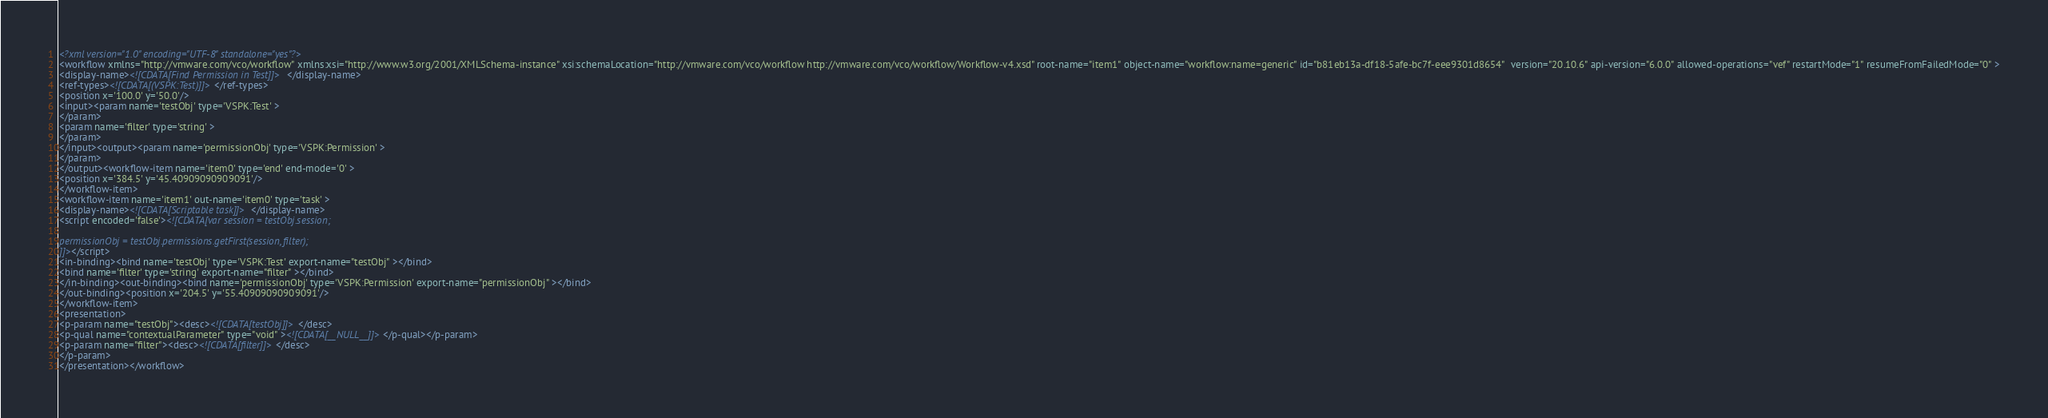Convert code to text. <code><loc_0><loc_0><loc_500><loc_500><_XML_><?xml version="1.0" encoding="UTF-8" standalone="yes"?>
<workflow xmlns="http://vmware.com/vco/workflow" xmlns:xsi="http://www.w3.org/2001/XMLSchema-instance" xsi:schemaLocation="http://vmware.com/vco/workflow http://vmware.com/vco/workflow/Workflow-v4.xsd" root-name="item1" object-name="workflow:name=generic" id="b81eb13a-df18-5afe-bc7f-eee9301d8654"  version="20.10.6" api-version="6.0.0" allowed-operations="vef" restartMode="1" resumeFromFailedMode="0" >
<display-name><![CDATA[Find Permission in Test]]></display-name>
<ref-types><![CDATA[(VSPK:Test)]]></ref-types>
<position x='100.0' y='50.0'/>
<input><param name='testObj' type='VSPK:Test' >
</param>
<param name='filter' type='string' >
</param>
</input><output><param name='permissionObj' type='VSPK:Permission' >
</param>
</output><workflow-item name='item0' type='end' end-mode='0' >
<position x='384.5' y='45.40909090909091'/>
</workflow-item>
<workflow-item name='item1' out-name='item0' type='task' >
<display-name><![CDATA[Scriptable task]]></display-name>
<script encoded='false'><![CDATA[var session = testObj.session;

permissionObj = testObj.permissions.getFirst(session, filter);
]]></script>
<in-binding><bind name='testObj' type='VSPK:Test' export-name="testObj" ></bind>
<bind name='filter' type='string' export-name="filter" ></bind>
</in-binding><out-binding><bind name='permissionObj' type='VSPK:Permission' export-name="permissionObj" ></bind>
</out-binding><position x='204.5' y='55.40909090909091'/>
</workflow-item>
<presentation>
<p-param name="testObj"><desc><![CDATA[testObj]]></desc>
<p-qual name="contextualParameter" type="void" ><![CDATA[__NULL__]]></p-qual></p-param>
<p-param name="filter"><desc><![CDATA[filter]]></desc>
</p-param>
</presentation></workflow></code> 